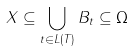<formula> <loc_0><loc_0><loc_500><loc_500>X \subseteq \bigcup _ { t \in L ( T ) } B _ { t } \subseteq \Omega</formula> 